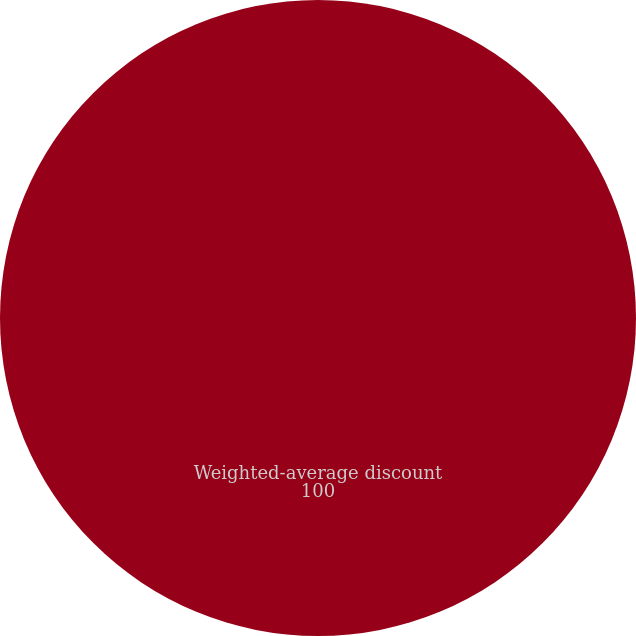Convert chart. <chart><loc_0><loc_0><loc_500><loc_500><pie_chart><fcel>Weighted-average discount<nl><fcel>100.0%<nl></chart> 